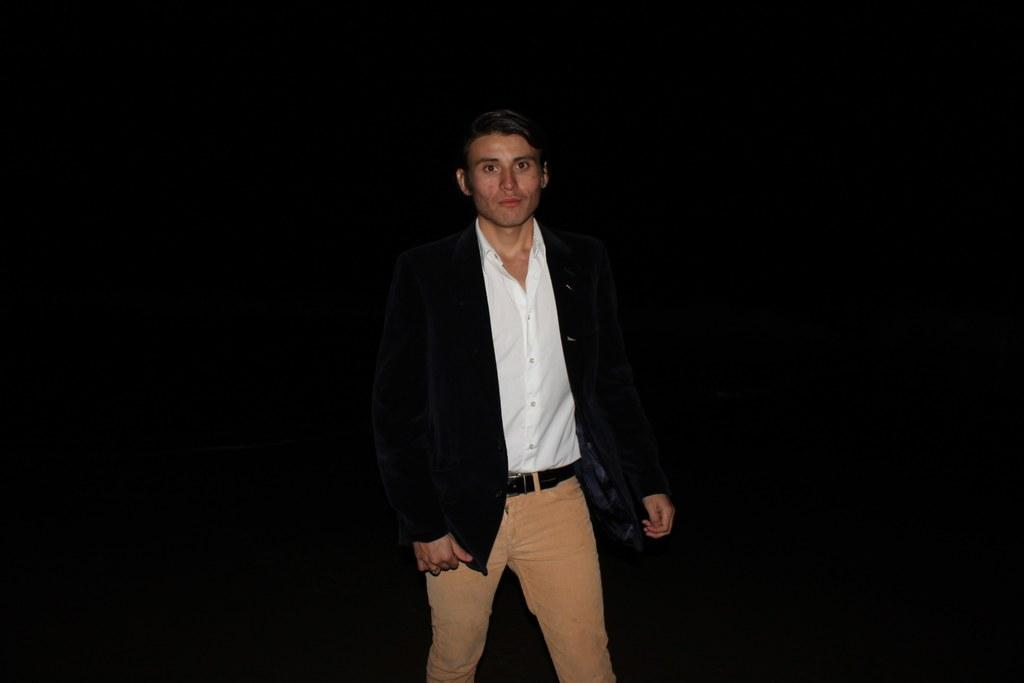What is the main subject of the image? The main subject of the image is a man standing. What type of clothing is the man wearing on his upper body? The man is wearing a shirt and a jacket. What type of clothing is the man wearing on his lower body? The man is wearing trousers. What accessory is the man wearing around his waist? The man is wearing a belt. What can be observed about the background of the image? The background of the image is dark. What type of limit is the man trying to overcome in the image? There is no indication of any limits or challenges in the image; it simply shows a man standing while wearing various articles of clothing. 